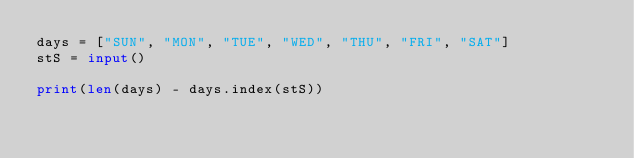Convert code to text. <code><loc_0><loc_0><loc_500><loc_500><_Python_>days = ["SUN", "MON", "TUE", "WED", "THU", "FRI", "SAT"]
stS = input()

print(len(days) - days.index(stS))</code> 